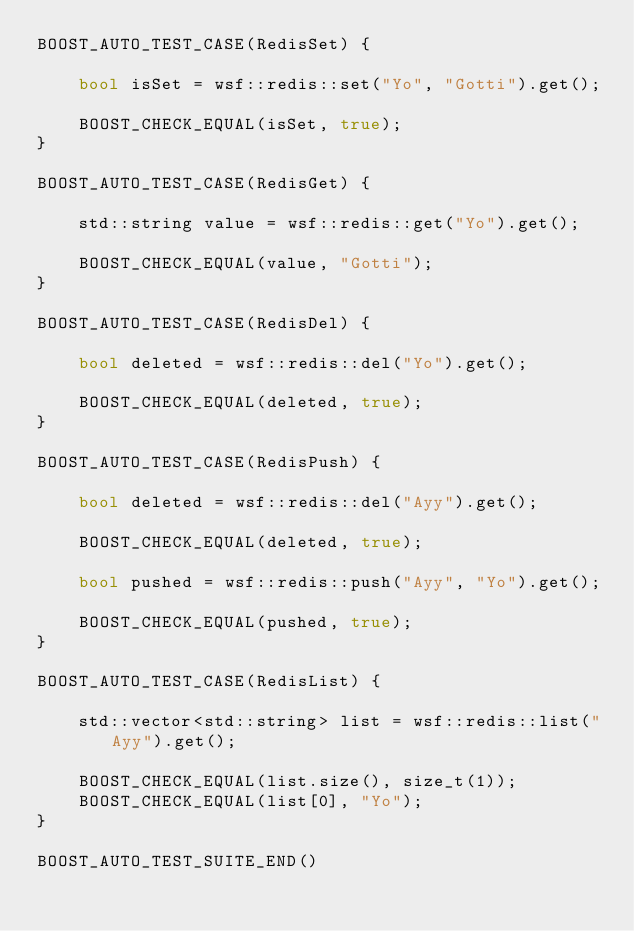<code> <loc_0><loc_0><loc_500><loc_500><_C++_>BOOST_AUTO_TEST_CASE(RedisSet) {

    bool isSet = wsf::redis::set("Yo", "Gotti").get();

    BOOST_CHECK_EQUAL(isSet, true);
}

BOOST_AUTO_TEST_CASE(RedisGet) {

    std::string value = wsf::redis::get("Yo").get();

    BOOST_CHECK_EQUAL(value, "Gotti");
}

BOOST_AUTO_TEST_CASE(RedisDel) {

    bool deleted = wsf::redis::del("Yo").get();

    BOOST_CHECK_EQUAL(deleted, true);
}

BOOST_AUTO_TEST_CASE(RedisPush) {
    
    bool deleted = wsf::redis::del("Ayy").get();

    BOOST_CHECK_EQUAL(deleted, true);

    bool pushed = wsf::redis::push("Ayy", "Yo").get();

    BOOST_CHECK_EQUAL(pushed, true);
}

BOOST_AUTO_TEST_CASE(RedisList) {

    std::vector<std::string> list = wsf::redis::list("Ayy").get();

    BOOST_CHECK_EQUAL(list.size(), size_t(1));
    BOOST_CHECK_EQUAL(list[0], "Yo");
}

BOOST_AUTO_TEST_SUITE_END()
</code> 